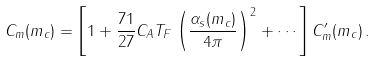<formula> <loc_0><loc_0><loc_500><loc_500>C _ { m } ( m _ { c } ) = \left [ 1 + \frac { 7 1 } { 2 7 } C _ { A } T _ { F } \left ( \frac { \alpha _ { s } ( m _ { c } ) } { 4 \pi } \right ) ^ { 2 } + \cdots \right ] C _ { m } ^ { \prime } ( m _ { c } ) \, .</formula> 